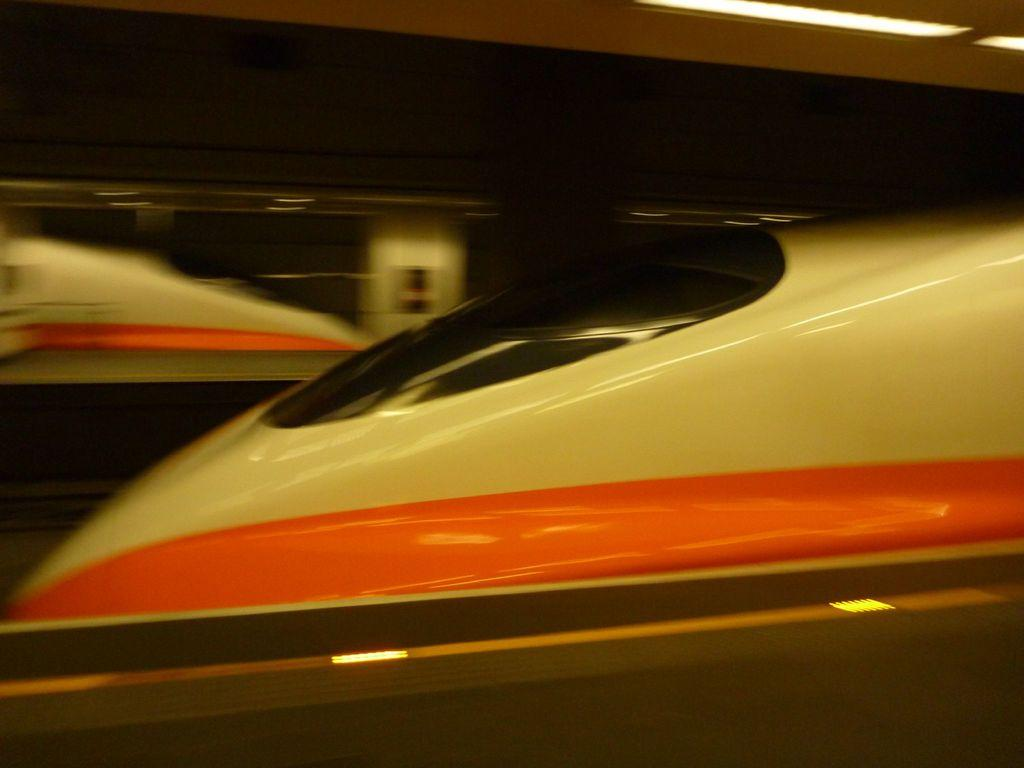What is the main subject of the image? There is a bullet train in the middle of the image. What can be seen at the top of the image? There is light at the top of the image. Is there any indication of a station or platform in the image? There might be a platform at the bottom of the image. How would you describe the background of the image? The background of the image is blurred. What type of oven is visible in the image? There is no oven present in the image. What is the belief system of the sand in the image? There is no sand present in the image, and therefore no belief system can be attributed to it. 